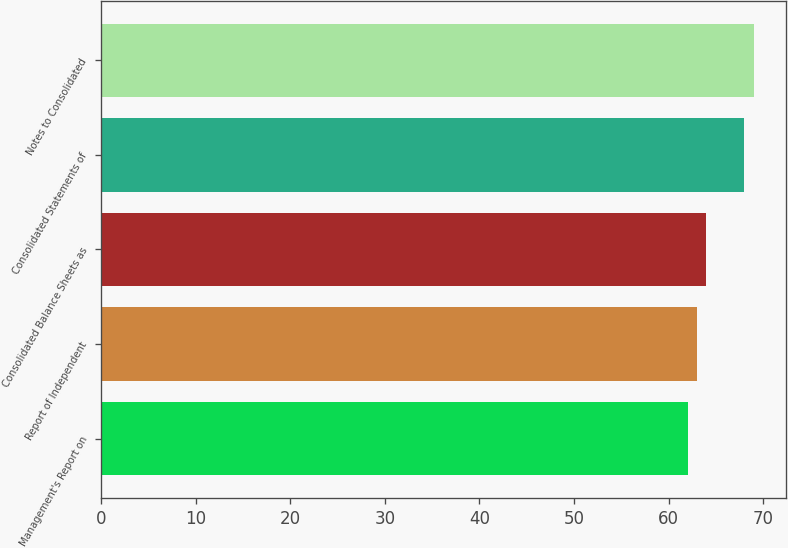Convert chart to OTSL. <chart><loc_0><loc_0><loc_500><loc_500><bar_chart><fcel>Management's Report on<fcel>Report of Independent<fcel>Consolidated Balance Sheets as<fcel>Consolidated Statements of<fcel>Notes to Consolidated<nl><fcel>62<fcel>63<fcel>64<fcel>68<fcel>69<nl></chart> 